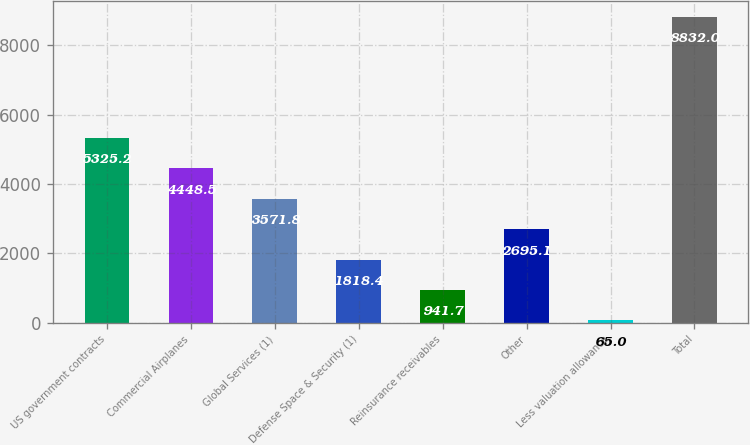Convert chart to OTSL. <chart><loc_0><loc_0><loc_500><loc_500><bar_chart><fcel>US government contracts<fcel>Commercial Airplanes<fcel>Global Services (1)<fcel>Defense Space & Security (1)<fcel>Reinsurance receivables<fcel>Other<fcel>Less valuation allowance<fcel>Total<nl><fcel>5325.2<fcel>4448.5<fcel>3571.8<fcel>1818.4<fcel>941.7<fcel>2695.1<fcel>65<fcel>8832<nl></chart> 